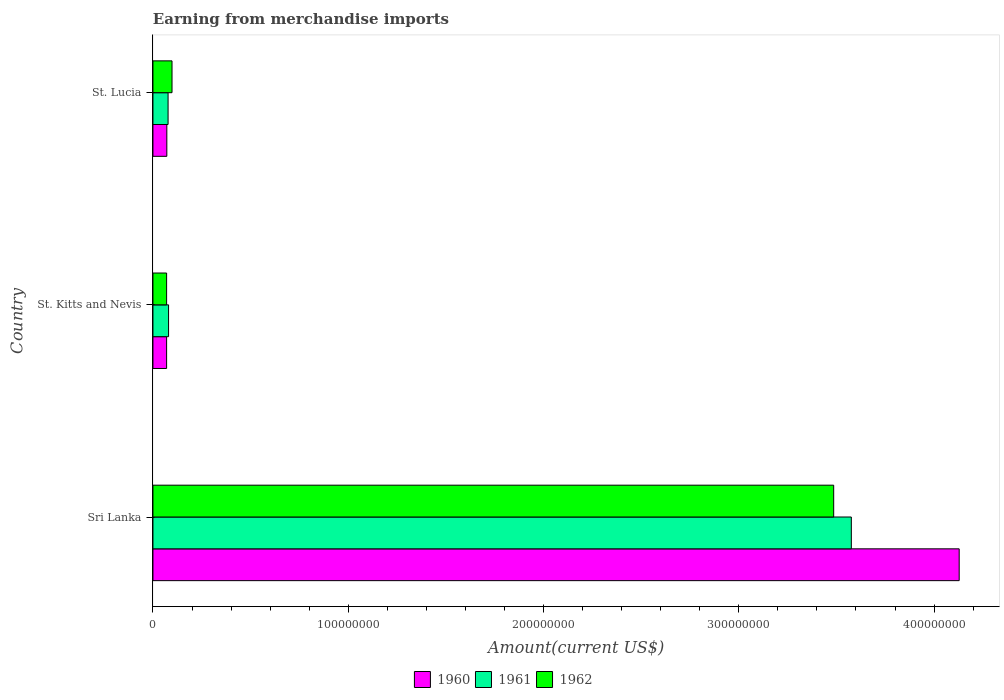What is the label of the 2nd group of bars from the top?
Your response must be concise. St. Kitts and Nevis. In how many cases, is the number of bars for a given country not equal to the number of legend labels?
Your response must be concise. 0. What is the amount earned from merchandise imports in 1962 in Sri Lanka?
Your response must be concise. 3.49e+08. Across all countries, what is the maximum amount earned from merchandise imports in 1960?
Your response must be concise. 4.13e+08. In which country was the amount earned from merchandise imports in 1960 maximum?
Make the answer very short. Sri Lanka. In which country was the amount earned from merchandise imports in 1961 minimum?
Give a very brief answer. St. Lucia. What is the total amount earned from merchandise imports in 1962 in the graph?
Your answer should be very brief. 3.65e+08. What is the difference between the amount earned from merchandise imports in 1961 in Sri Lanka and that in St. Kitts and Nevis?
Give a very brief answer. 3.50e+08. What is the difference between the amount earned from merchandise imports in 1962 in St. Kitts and Nevis and the amount earned from merchandise imports in 1960 in St. Lucia?
Provide a succinct answer. -1.07e+05. What is the average amount earned from merchandise imports in 1961 per country?
Offer a terse response. 1.24e+08. What is the ratio of the amount earned from merchandise imports in 1962 in Sri Lanka to that in St. Lucia?
Your answer should be compact. 35.69. Is the difference between the amount earned from merchandise imports in 1961 in Sri Lanka and St. Kitts and Nevis greater than the difference between the amount earned from merchandise imports in 1960 in Sri Lanka and St. Kitts and Nevis?
Provide a short and direct response. No. What is the difference between the highest and the second highest amount earned from merchandise imports in 1962?
Ensure brevity in your answer.  3.39e+08. What is the difference between the highest and the lowest amount earned from merchandise imports in 1960?
Provide a succinct answer. 4.06e+08. What does the 3rd bar from the top in Sri Lanka represents?
Offer a terse response. 1960. How many countries are there in the graph?
Give a very brief answer. 3. Does the graph contain any zero values?
Ensure brevity in your answer.  No. Where does the legend appear in the graph?
Make the answer very short. Bottom center. What is the title of the graph?
Your response must be concise. Earning from merchandise imports. Does "2010" appear as one of the legend labels in the graph?
Ensure brevity in your answer.  No. What is the label or title of the X-axis?
Provide a short and direct response. Amount(current US$). What is the label or title of the Y-axis?
Offer a terse response. Country. What is the Amount(current US$) of 1960 in Sri Lanka?
Give a very brief answer. 4.13e+08. What is the Amount(current US$) in 1961 in Sri Lanka?
Offer a very short reply. 3.58e+08. What is the Amount(current US$) of 1962 in Sri Lanka?
Provide a short and direct response. 3.49e+08. What is the Amount(current US$) of 1960 in St. Kitts and Nevis?
Offer a very short reply. 7.00e+06. What is the Amount(current US$) in 1961 in St. Kitts and Nevis?
Provide a succinct answer. 8.00e+06. What is the Amount(current US$) of 1962 in St. Kitts and Nevis?
Offer a very short reply. 7.00e+06. What is the Amount(current US$) in 1960 in St. Lucia?
Provide a succinct answer. 7.11e+06. What is the Amount(current US$) in 1961 in St. Lucia?
Keep it short and to the point. 7.75e+06. What is the Amount(current US$) in 1962 in St. Lucia?
Provide a short and direct response. 9.77e+06. Across all countries, what is the maximum Amount(current US$) in 1960?
Ensure brevity in your answer.  4.13e+08. Across all countries, what is the maximum Amount(current US$) in 1961?
Offer a very short reply. 3.58e+08. Across all countries, what is the maximum Amount(current US$) in 1962?
Offer a terse response. 3.49e+08. Across all countries, what is the minimum Amount(current US$) in 1960?
Your response must be concise. 7.00e+06. Across all countries, what is the minimum Amount(current US$) in 1961?
Offer a very short reply. 7.75e+06. Across all countries, what is the minimum Amount(current US$) in 1962?
Provide a short and direct response. 7.00e+06. What is the total Amount(current US$) of 1960 in the graph?
Your answer should be compact. 4.27e+08. What is the total Amount(current US$) of 1961 in the graph?
Your answer should be very brief. 3.73e+08. What is the total Amount(current US$) in 1962 in the graph?
Make the answer very short. 3.65e+08. What is the difference between the Amount(current US$) of 1960 in Sri Lanka and that in St. Kitts and Nevis?
Keep it short and to the point. 4.06e+08. What is the difference between the Amount(current US$) in 1961 in Sri Lanka and that in St. Kitts and Nevis?
Make the answer very short. 3.50e+08. What is the difference between the Amount(current US$) of 1962 in Sri Lanka and that in St. Kitts and Nevis?
Your response must be concise. 3.42e+08. What is the difference between the Amount(current US$) in 1960 in Sri Lanka and that in St. Lucia?
Your response must be concise. 4.06e+08. What is the difference between the Amount(current US$) of 1961 in Sri Lanka and that in St. Lucia?
Provide a succinct answer. 3.50e+08. What is the difference between the Amount(current US$) in 1962 in Sri Lanka and that in St. Lucia?
Your answer should be very brief. 3.39e+08. What is the difference between the Amount(current US$) in 1960 in St. Kitts and Nevis and that in St. Lucia?
Your response must be concise. -1.07e+05. What is the difference between the Amount(current US$) in 1961 in St. Kitts and Nevis and that in St. Lucia?
Your answer should be very brief. 2.48e+05. What is the difference between the Amount(current US$) of 1962 in St. Kitts and Nevis and that in St. Lucia?
Offer a very short reply. -2.77e+06. What is the difference between the Amount(current US$) in 1960 in Sri Lanka and the Amount(current US$) in 1961 in St. Kitts and Nevis?
Keep it short and to the point. 4.05e+08. What is the difference between the Amount(current US$) in 1960 in Sri Lanka and the Amount(current US$) in 1962 in St. Kitts and Nevis?
Your answer should be compact. 4.06e+08. What is the difference between the Amount(current US$) of 1961 in Sri Lanka and the Amount(current US$) of 1962 in St. Kitts and Nevis?
Make the answer very short. 3.51e+08. What is the difference between the Amount(current US$) of 1960 in Sri Lanka and the Amount(current US$) of 1961 in St. Lucia?
Your answer should be compact. 4.05e+08. What is the difference between the Amount(current US$) of 1960 in Sri Lanka and the Amount(current US$) of 1962 in St. Lucia?
Offer a very short reply. 4.03e+08. What is the difference between the Amount(current US$) in 1961 in Sri Lanka and the Amount(current US$) in 1962 in St. Lucia?
Your response must be concise. 3.48e+08. What is the difference between the Amount(current US$) in 1960 in St. Kitts and Nevis and the Amount(current US$) in 1961 in St. Lucia?
Offer a terse response. -7.52e+05. What is the difference between the Amount(current US$) in 1960 in St. Kitts and Nevis and the Amount(current US$) in 1962 in St. Lucia?
Provide a succinct answer. -2.77e+06. What is the difference between the Amount(current US$) of 1961 in St. Kitts and Nevis and the Amount(current US$) of 1962 in St. Lucia?
Your answer should be compact. -1.77e+06. What is the average Amount(current US$) in 1960 per country?
Keep it short and to the point. 1.42e+08. What is the average Amount(current US$) in 1961 per country?
Keep it short and to the point. 1.24e+08. What is the average Amount(current US$) in 1962 per country?
Make the answer very short. 1.22e+08. What is the difference between the Amount(current US$) of 1960 and Amount(current US$) of 1961 in Sri Lanka?
Keep it short and to the point. 5.52e+07. What is the difference between the Amount(current US$) in 1960 and Amount(current US$) in 1962 in Sri Lanka?
Ensure brevity in your answer.  6.43e+07. What is the difference between the Amount(current US$) of 1961 and Amount(current US$) of 1962 in Sri Lanka?
Give a very brief answer. 9.03e+06. What is the difference between the Amount(current US$) of 1960 and Amount(current US$) of 1961 in St. Kitts and Nevis?
Your answer should be compact. -1.00e+06. What is the difference between the Amount(current US$) in 1960 and Amount(current US$) in 1962 in St. Kitts and Nevis?
Provide a succinct answer. 0. What is the difference between the Amount(current US$) in 1961 and Amount(current US$) in 1962 in St. Kitts and Nevis?
Your answer should be compact. 1.00e+06. What is the difference between the Amount(current US$) in 1960 and Amount(current US$) in 1961 in St. Lucia?
Your answer should be very brief. -6.46e+05. What is the difference between the Amount(current US$) of 1960 and Amount(current US$) of 1962 in St. Lucia?
Keep it short and to the point. -2.66e+06. What is the difference between the Amount(current US$) of 1961 and Amount(current US$) of 1962 in St. Lucia?
Keep it short and to the point. -2.02e+06. What is the ratio of the Amount(current US$) in 1960 in Sri Lanka to that in St. Kitts and Nevis?
Give a very brief answer. 58.98. What is the ratio of the Amount(current US$) in 1961 in Sri Lanka to that in St. Kitts and Nevis?
Give a very brief answer. 44.7. What is the ratio of the Amount(current US$) of 1962 in Sri Lanka to that in St. Kitts and Nevis?
Offer a very short reply. 49.8. What is the ratio of the Amount(current US$) of 1960 in Sri Lanka to that in St. Lucia?
Give a very brief answer. 58.09. What is the ratio of the Amount(current US$) in 1961 in Sri Lanka to that in St. Lucia?
Give a very brief answer. 46.13. What is the ratio of the Amount(current US$) of 1962 in Sri Lanka to that in St. Lucia?
Your answer should be very brief. 35.69. What is the ratio of the Amount(current US$) in 1960 in St. Kitts and Nevis to that in St. Lucia?
Keep it short and to the point. 0.98. What is the ratio of the Amount(current US$) in 1961 in St. Kitts and Nevis to that in St. Lucia?
Make the answer very short. 1.03. What is the ratio of the Amount(current US$) of 1962 in St. Kitts and Nevis to that in St. Lucia?
Ensure brevity in your answer.  0.72. What is the difference between the highest and the second highest Amount(current US$) of 1960?
Your answer should be very brief. 4.06e+08. What is the difference between the highest and the second highest Amount(current US$) in 1961?
Ensure brevity in your answer.  3.50e+08. What is the difference between the highest and the second highest Amount(current US$) of 1962?
Offer a very short reply. 3.39e+08. What is the difference between the highest and the lowest Amount(current US$) in 1960?
Provide a succinct answer. 4.06e+08. What is the difference between the highest and the lowest Amount(current US$) of 1961?
Your answer should be compact. 3.50e+08. What is the difference between the highest and the lowest Amount(current US$) in 1962?
Your answer should be compact. 3.42e+08. 